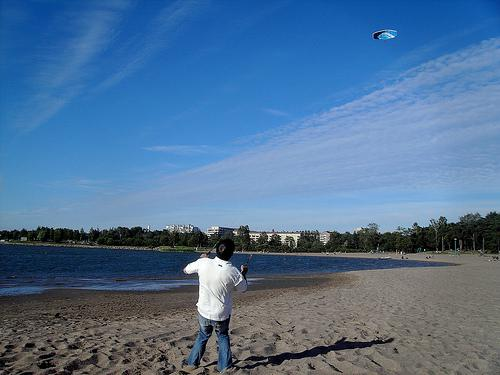Question: when color is the man's shirt?
Choices:
A. Grey.
B. Black.
C. White.
D. Yellow.
Answer with the letter. Answer: C Question: what is the man flying?
Choices:
A. A radio controlled airplane.
B. A kite.
C. A drone.
D. A radio controlled helicopter.
Answer with the letter. Answer: B Question: why is it so bright?
Choices:
A. The light bulb is too bright.
B. You are looking directly at the light.
C. There are no clouds.
D. Sunny.
Answer with the letter. Answer: D 